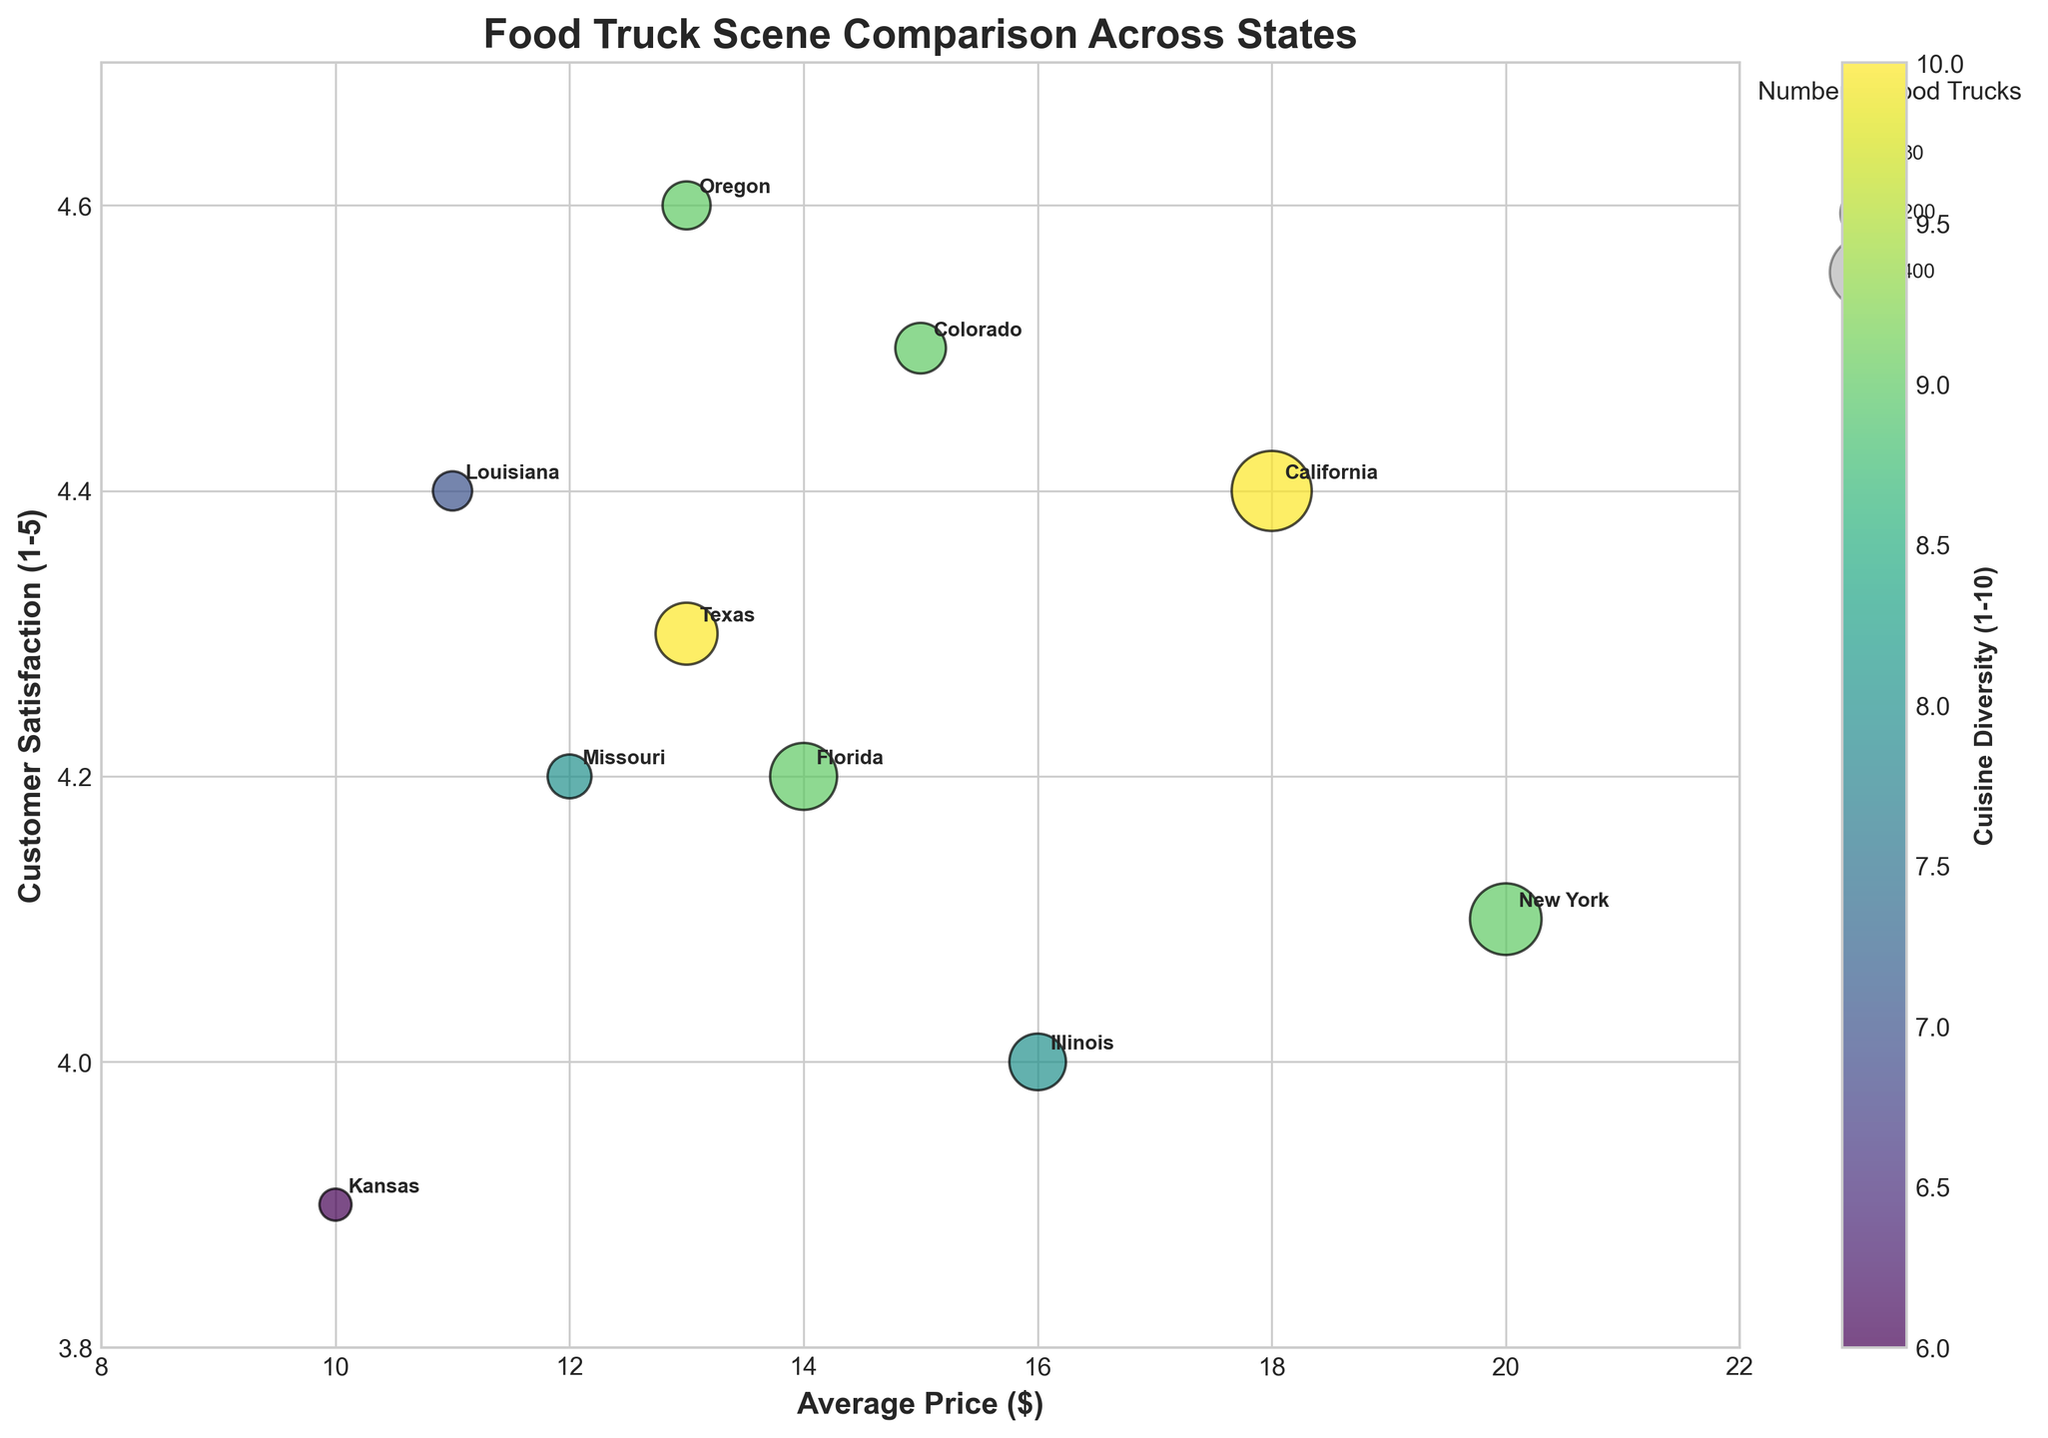What is the title of the figure? The titles of graphs are typically located at the top center. In this case, the title reads 'Food Truck Scene Comparison Across States'.
Answer: Food Truck Scene Comparison Across States Which state has the highest customer satisfaction rating? By examining the y-axis, which represents customer satisfaction, Oregon has the highest rating at 4.6.
Answer: Oregon What is the average price for food trucks in Texas? Check the x-axis where Texas is annotated; Texas aligns with $13 on the x-axis for average prices.
Answer: $13 How many states have a cuisine diversity score of 10? Observe the color gradient bar representing cuisine diversity; California and Texas both have a cuisine diversity score of 10.
Answer: 2 Which state has the largest bubble? The bubble size represents the number of food trucks. California has the largest bubble, indicating it has the highest number of food trucks.
Answer: California Between New York and Missouri, which state has higher customer satisfaction? Look at the y-axis values for both states; Missouri's customer satisfaction is 4.2, while New York's is 4.1. Missouri has a higher customer satisfaction.
Answer: Missouri How much more expensive are the average prices in New York compared to Kansas? Kansas has an average price of $10, and New York has $20. So, the difference is $20 - $10.
Answer: $10 Which states have customer satisfaction ratings below 4.2? By viewing the y-axis and annotating labels, Kansas (3.9) and New York (4.1) have ratings below 4.2.
Answer: Kansas, New York What is the most expensive average price among all the states? Check the x-axis for the highest value; New York has the highest average price of $20.
Answer: $20 How does the cuisine diversity of Missouri compare to Louisiana? Look at the color and corresponding scale for both states; Missouri has a score of 8, while Louisiana has 7. Therefore, Missouri has a higher cuisine diversity.
Answer: Missouri 